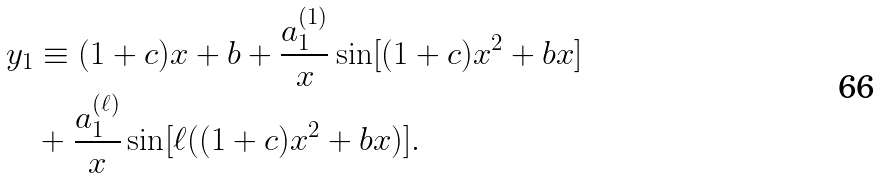<formula> <loc_0><loc_0><loc_500><loc_500>y _ { 1 } & \equiv ( 1 + c ) x + b + \frac { a ^ { ( 1 ) } _ { 1 } } { x } \sin [ ( 1 + c ) x ^ { 2 } + b x ] \\ & + \frac { a ^ { ( \ell ) } _ { 1 } } { x } \sin [ \ell ( ( 1 + c ) x ^ { 2 } + b x ) ] .</formula> 